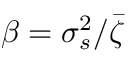<formula> <loc_0><loc_0><loc_500><loc_500>\beta = \sigma _ { s } ^ { 2 } / \bar { \zeta }</formula> 